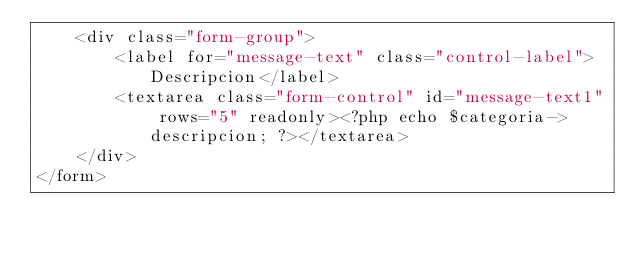Convert code to text. <code><loc_0><loc_0><loc_500><loc_500><_PHP_>    <div class="form-group">
        <label for="message-text" class="control-label">Descripcion</label>
        <textarea class="form-control" id="message-text1" rows="5" readonly><?php echo $categoria->descripcion; ?></textarea>
    </div>
</form></code> 